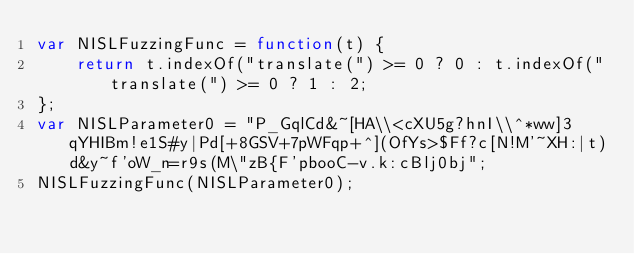<code> <loc_0><loc_0><loc_500><loc_500><_JavaScript_>var NISLFuzzingFunc = function(t) {
    return t.indexOf("translate(") >= 0 ? 0 : t.indexOf("translate(") >= 0 ? 1 : 2;
};
var NISLParameter0 = "P_GqlCd&~[HA\\<cXU5g?hnI\\^*ww]3qYHIBm!e1S#y|Pd[+8GSV+7pWFqp+^](OfYs>$Ff?c[N!M'~XH:|t)d&y~f'oW_n=r9s(M\"zB{F'pbooC-v.k:cBlj0bj";
NISLFuzzingFunc(NISLParameter0);
</code> 